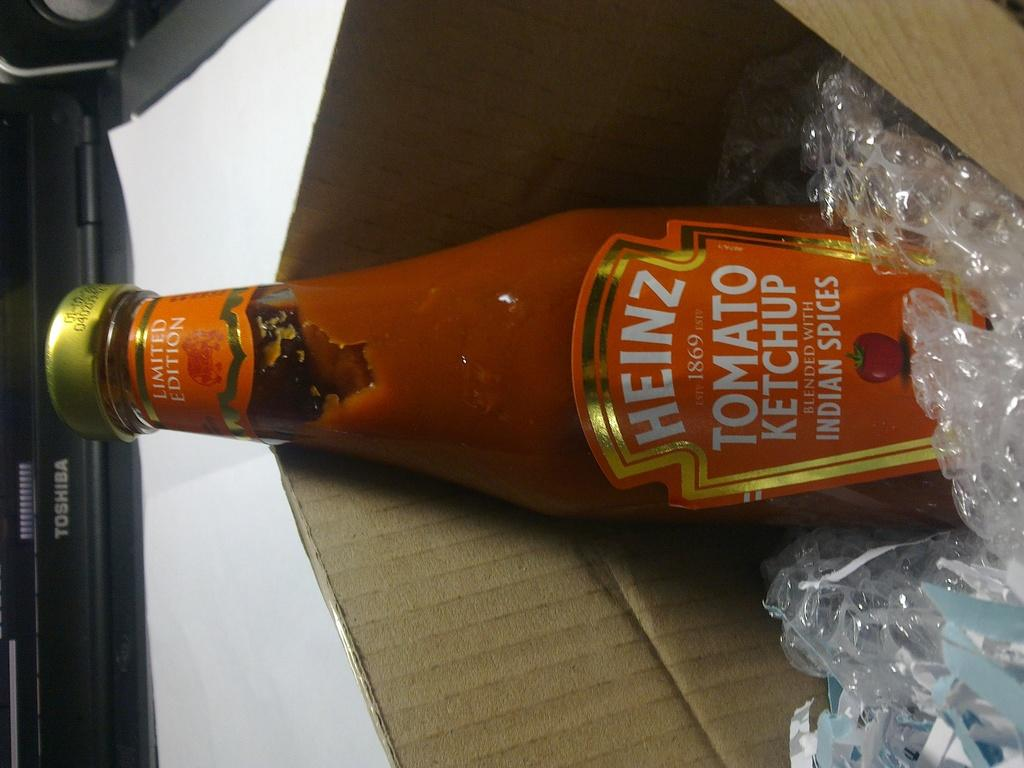<image>
Render a clear and concise summary of the photo. The word Heinz that is on a bottle 